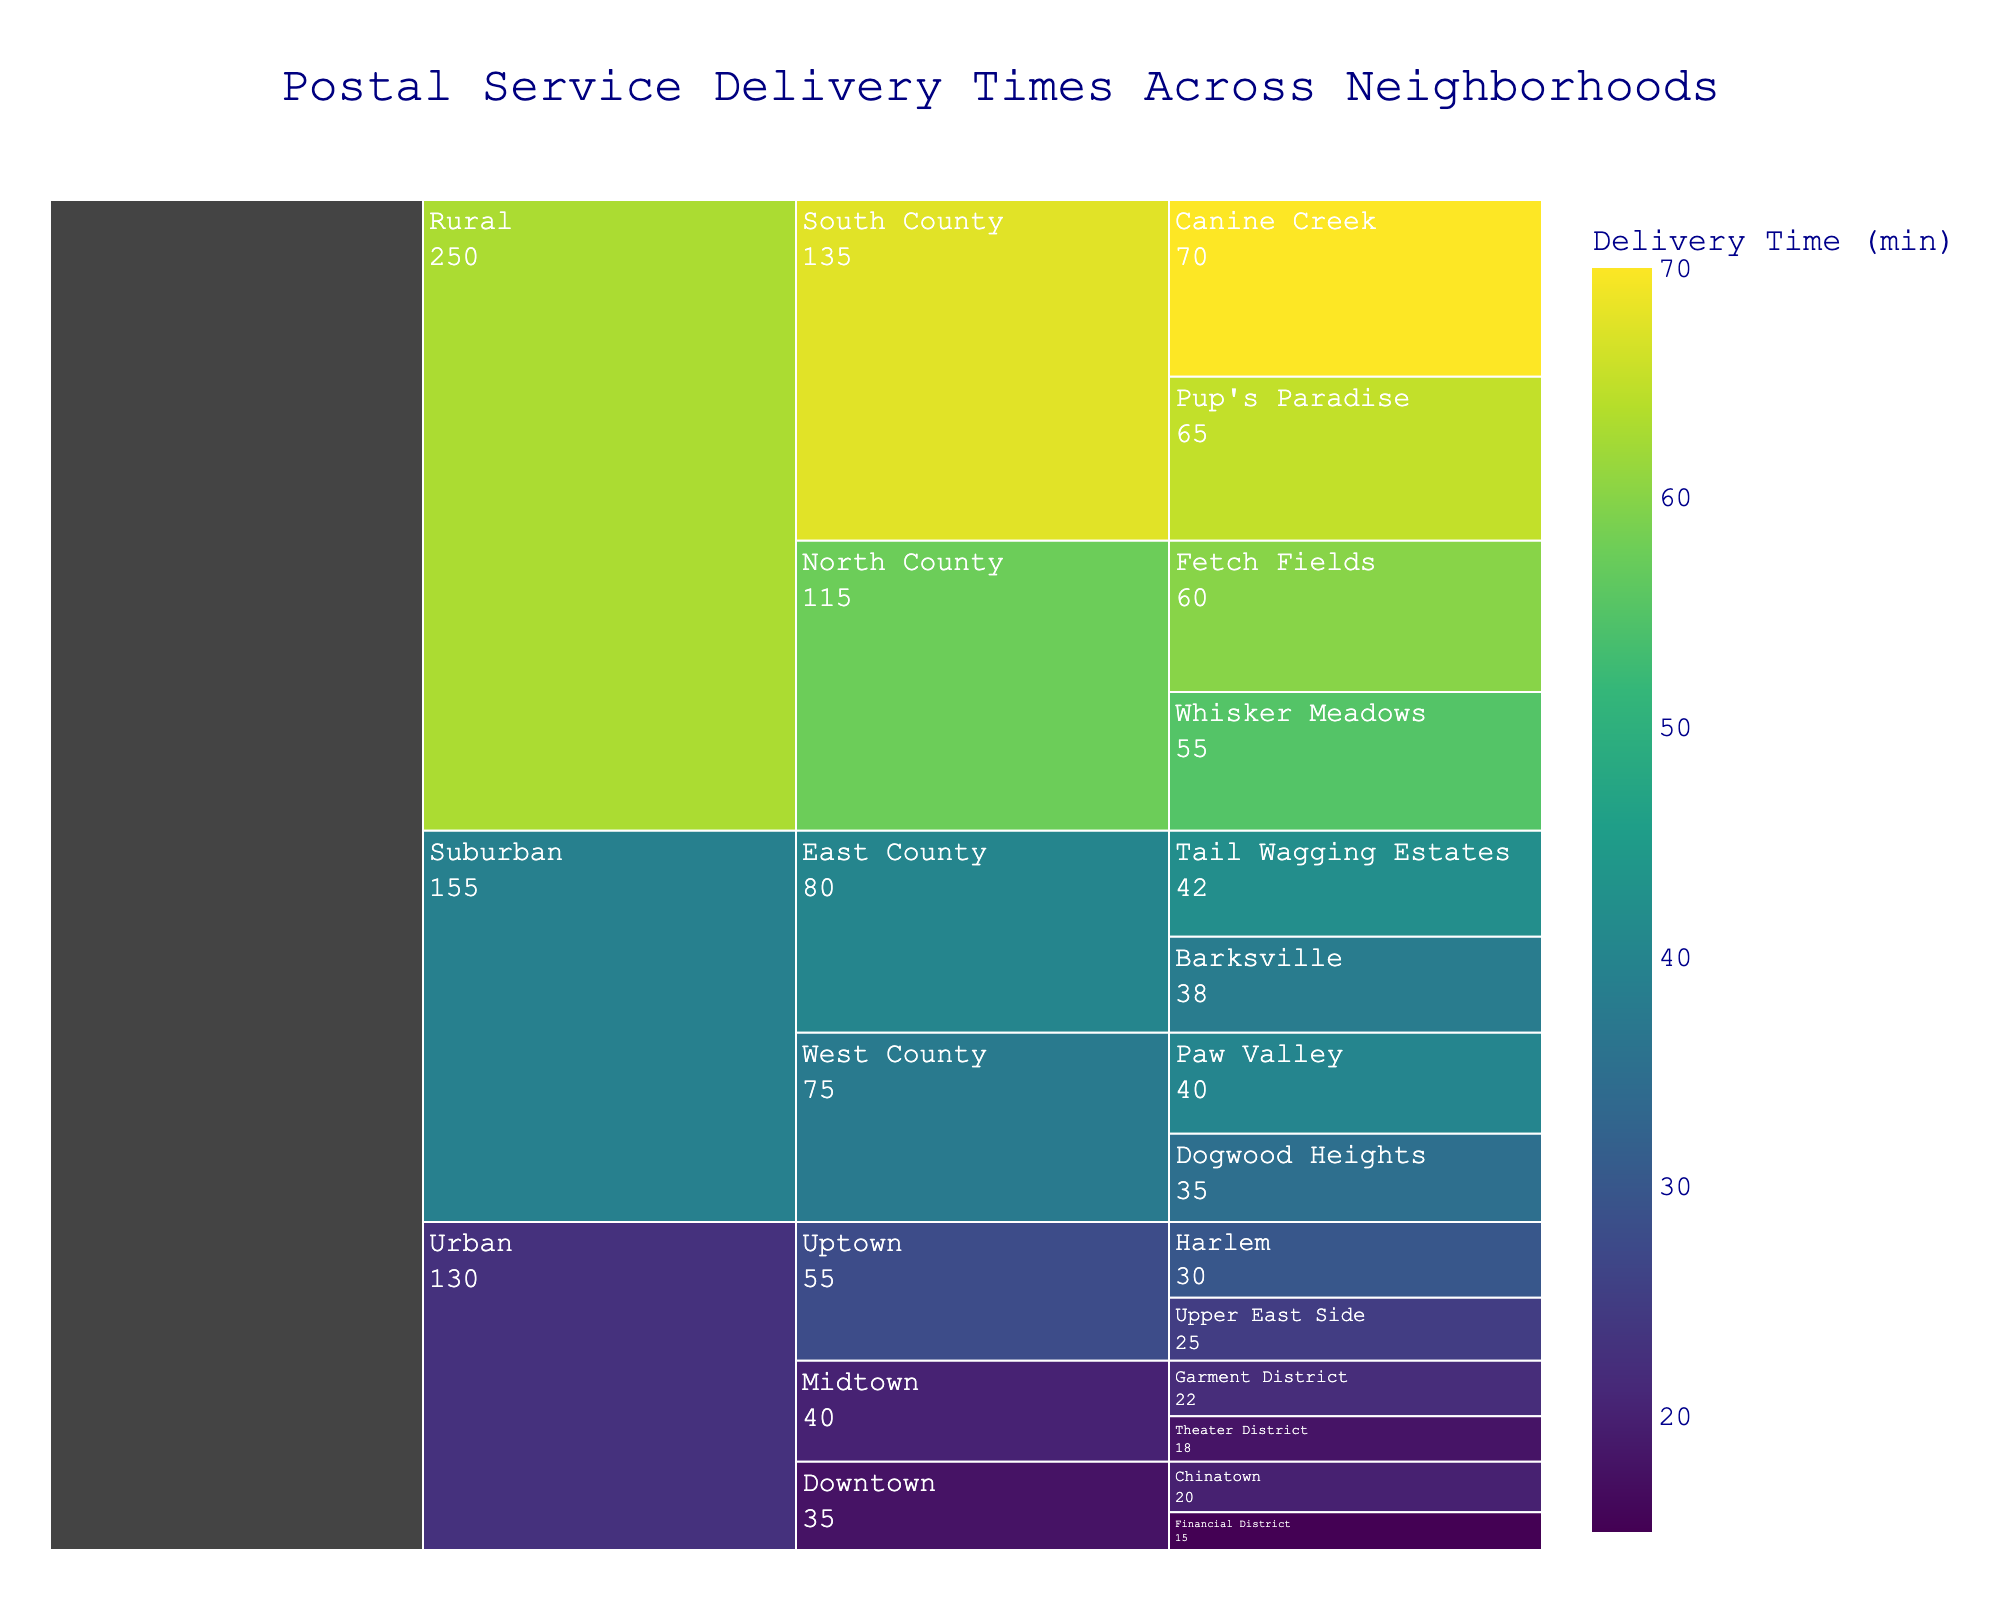What's the average delivery time for the Financial District? The icicle chart shows the Financial District under the Downtown region of the Urban area. The text information provided in the chart shows an average delivery time of 15 minutes.
Answer: 15 minutes Which neighborhood in the Urban Uptown region has the longer delivery time? In the Uptown region of the Urban area, the chart lists Harlem and the Upper East Side. Harlem has a delivery time of 30 minutes while the Upper East Side has 25 minutes.
Answer: Harlem Which suburban neighborhood, Dogwood Heights or Paw Valley, has a shorter delivery time? Dogwood Heights and Paw Valley are in the West County region of the Suburban area. Dogwood Heights has a delivery time of 35 minutes, whereas Paw Valley has 40 minutes.
Answer: Dogwood Heights What is the delivery time difference between Whisker Meadows and Canine Creek? Whisker Meadows in the North County region of the Rural area has a delivery time of 55 minutes, while Canine Creek in the South County region of the Rural area has a delivery time of 70 minutes. The difference is 70 - 55 = 15 minutes.
Answer: 15 minutes Which area has the highest average delivery time? Looking at the three areas (Urban, Suburban, and Rural), the Rural area shows the highest delivery times, with neighborhoods like Canine Creek at 70 minutes and Pup's Paradise at 65 minutes.
Answer: Rural What is the average delivery time across the neighborhoods in Digital Farm City? This question appears to be incorrectly stated as Digital Farm City is not present in the data. A correct way to phrase this might be to calculate the average time for an existing region.
Answer: N/A Which region in the Urban area has the shortest average delivery time? The Urban area has three regions: Downtown, Midtown, and Uptown. Summing and averaging, Downtown has (15+20)/2 = 17.5, Midtown has (18+22)/2 = 20, and Uptown has (25+30)/2 = 27.5. Thus, Downtown has the shortest average delivery time.
Answer: Downtown How much longer is the delivery time for Chinatown compared to the Theater District? Chinatown (20 minutes) is part of Downtown in the Urban area; Theater District (18 minutes) is part of Midtown. Thus, the difference is 20 - 18 = 2 minutes.
Answer: 2 minutes Which neighborhood in East County has the longer delivery time, Barksville or Tail Wagging Estates? East County in the Suburban area has Barksville with a delivery time of 38 minutes and Tail Wagging Estates with 42 minutes.
Answer: Tail Wagging Estates What is the combined delivery time for Whisker Meadows and Fetch Fields? Whisker Meadows (55 minutes) and Fetch Fields (60 minutes) are part of North County in the Rural area. Combined, the delivery time is 55 + 60 = 115 minutes.
Answer: 115 minutes 